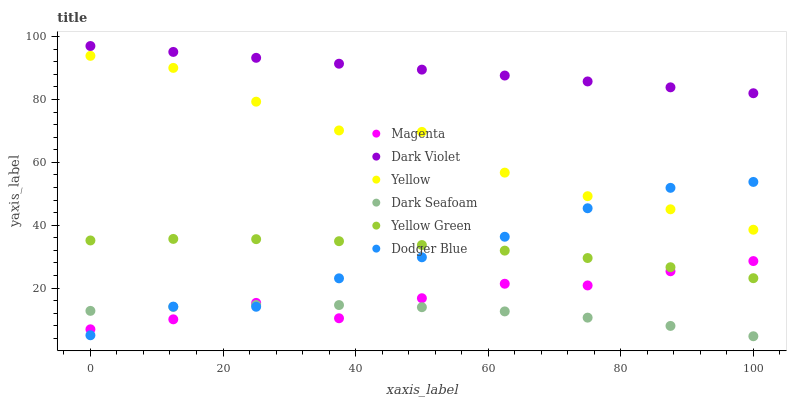Does Dark Seafoam have the minimum area under the curve?
Answer yes or no. Yes. Does Dark Violet have the maximum area under the curve?
Answer yes or no. Yes. Does Yellow have the minimum area under the curve?
Answer yes or no. No. Does Yellow have the maximum area under the curve?
Answer yes or no. No. Is Dark Violet the smoothest?
Answer yes or no. Yes. Is Yellow the roughest?
Answer yes or no. Yes. Is Dark Seafoam the smoothest?
Answer yes or no. No. Is Dark Seafoam the roughest?
Answer yes or no. No. Does Dark Seafoam have the lowest value?
Answer yes or no. Yes. Does Yellow have the lowest value?
Answer yes or no. No. Does Dark Violet have the highest value?
Answer yes or no. Yes. Does Yellow have the highest value?
Answer yes or no. No. Is Dodger Blue less than Dark Violet?
Answer yes or no. Yes. Is Dark Violet greater than Dark Seafoam?
Answer yes or no. Yes. Does Magenta intersect Dodger Blue?
Answer yes or no. Yes. Is Magenta less than Dodger Blue?
Answer yes or no. No. Is Magenta greater than Dodger Blue?
Answer yes or no. No. Does Dodger Blue intersect Dark Violet?
Answer yes or no. No. 